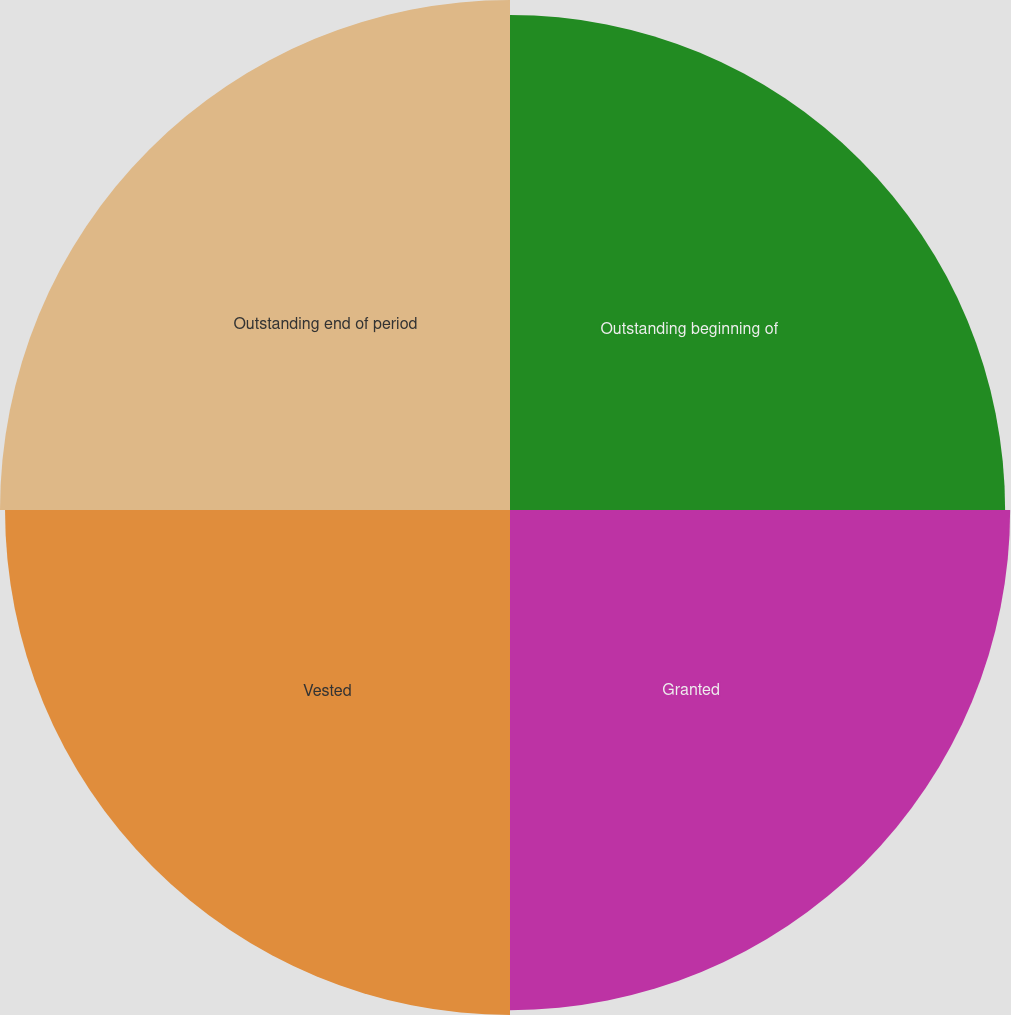Convert chart. <chart><loc_0><loc_0><loc_500><loc_500><pie_chart><fcel>Outstanding beginning of<fcel>Granted<fcel>Vested<fcel>Outstanding end of period<nl><fcel>24.63%<fcel>24.88%<fcel>25.12%<fcel>25.37%<nl></chart> 